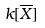Convert formula to latex. <formula><loc_0><loc_0><loc_500><loc_500>k [ \overline { X } ]</formula> 